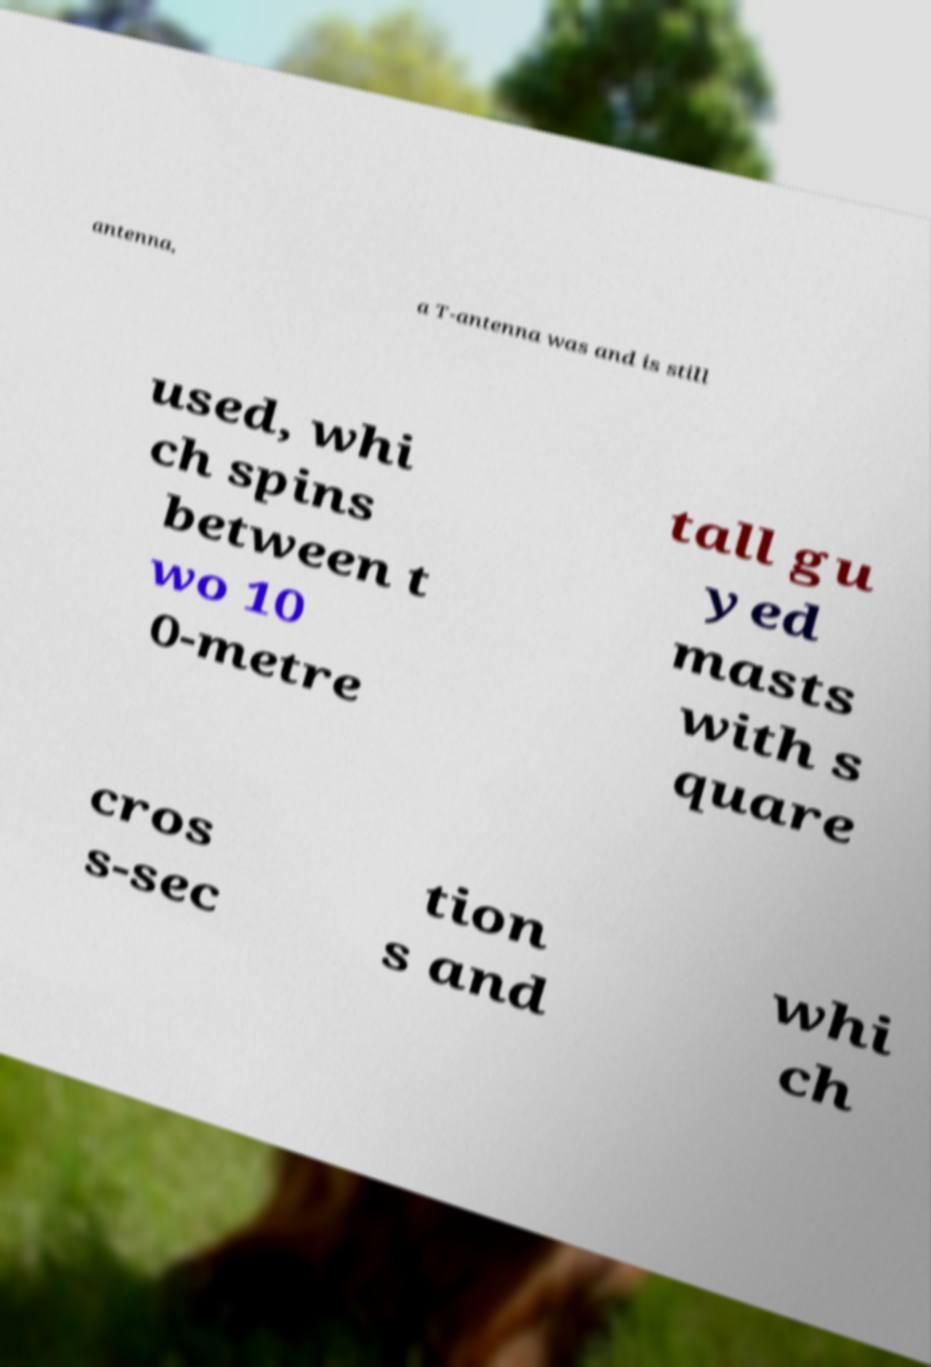Can you accurately transcribe the text from the provided image for me? antenna, a T-antenna was and is still used, whi ch spins between t wo 10 0-metre tall gu yed masts with s quare cros s-sec tion s and whi ch 